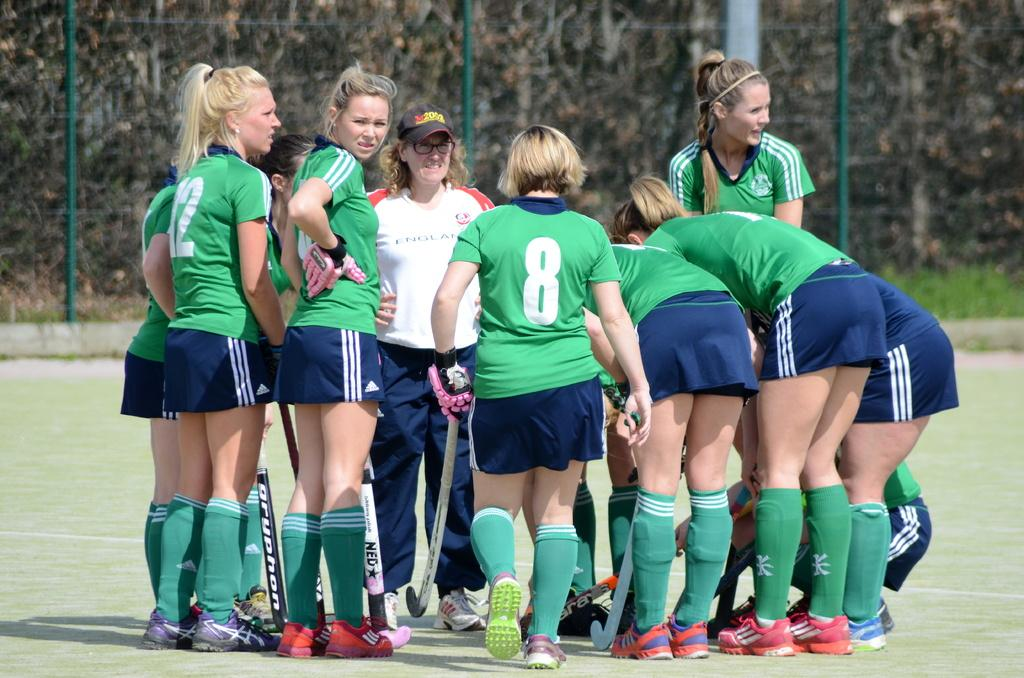<image>
Summarize the visual content of the image. the number 8 on the back of a jersey 